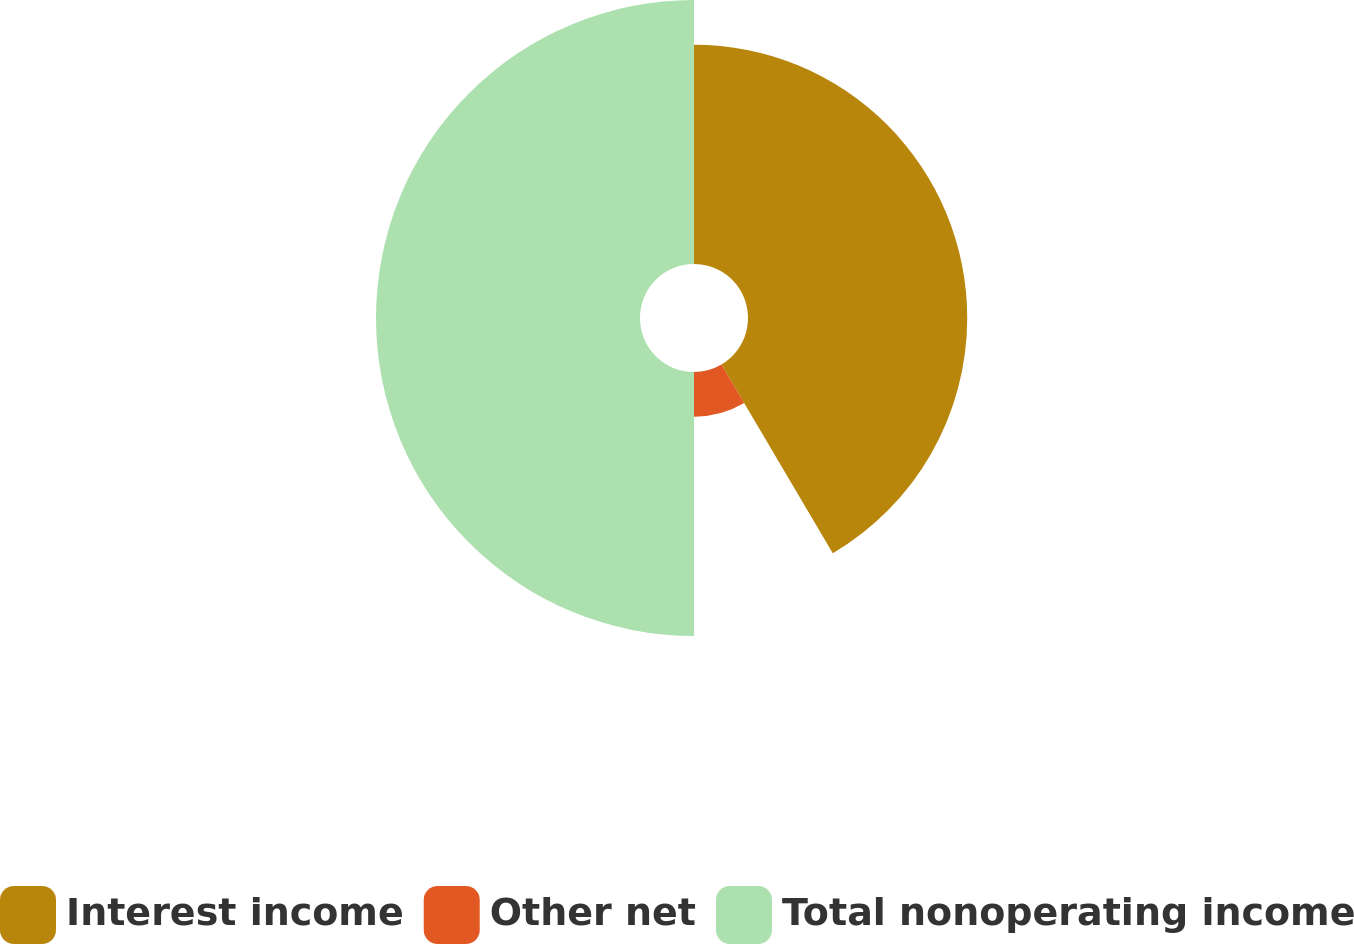Convert chart to OTSL. <chart><loc_0><loc_0><loc_500><loc_500><pie_chart><fcel>Interest income<fcel>Other net<fcel>Total nonoperating income<nl><fcel>41.52%<fcel>8.48%<fcel>50.0%<nl></chart> 